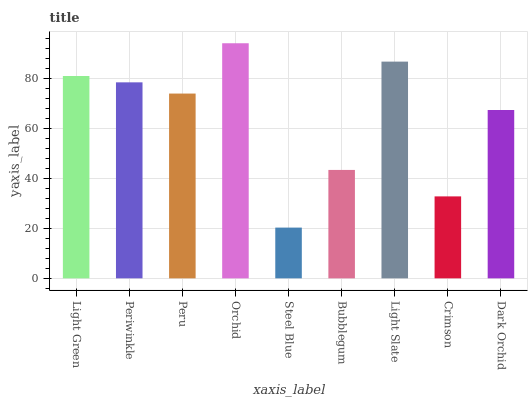Is Steel Blue the minimum?
Answer yes or no. Yes. Is Orchid the maximum?
Answer yes or no. Yes. Is Periwinkle the minimum?
Answer yes or no. No. Is Periwinkle the maximum?
Answer yes or no. No. Is Light Green greater than Periwinkle?
Answer yes or no. Yes. Is Periwinkle less than Light Green?
Answer yes or no. Yes. Is Periwinkle greater than Light Green?
Answer yes or no. No. Is Light Green less than Periwinkle?
Answer yes or no. No. Is Peru the high median?
Answer yes or no. Yes. Is Peru the low median?
Answer yes or no. Yes. Is Light Green the high median?
Answer yes or no. No. Is Periwinkle the low median?
Answer yes or no. No. 